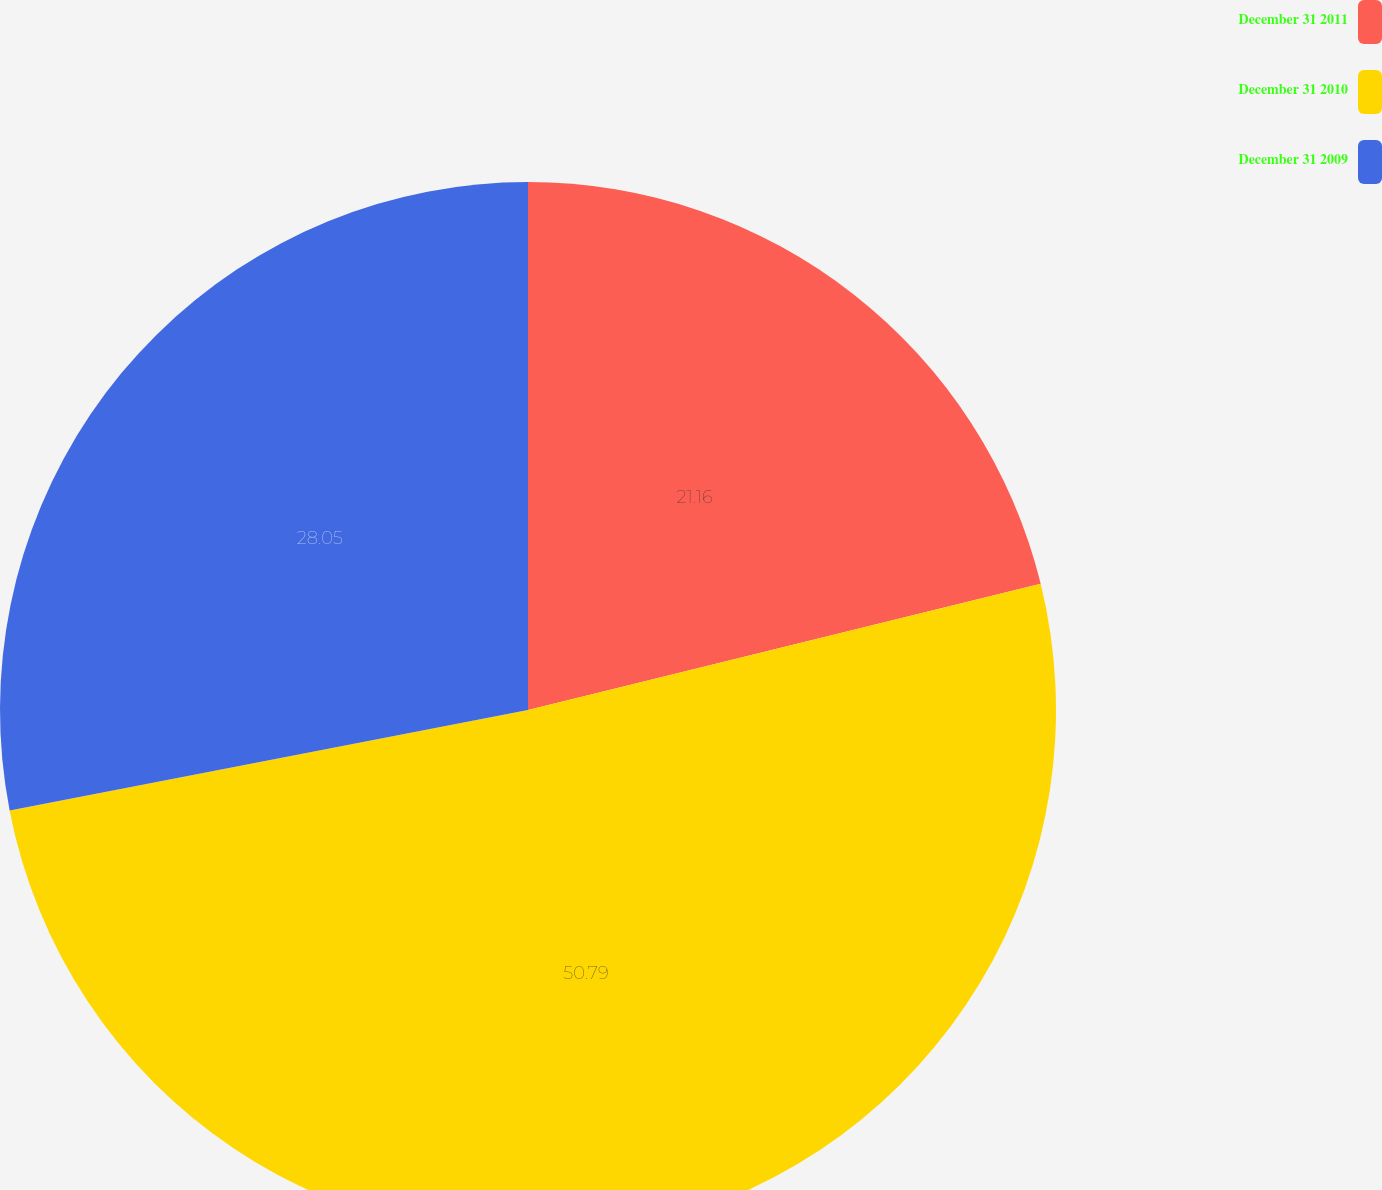Convert chart. <chart><loc_0><loc_0><loc_500><loc_500><pie_chart><fcel>December 31 2011<fcel>December 31 2010<fcel>December 31 2009<nl><fcel>21.16%<fcel>50.79%<fcel>28.05%<nl></chart> 